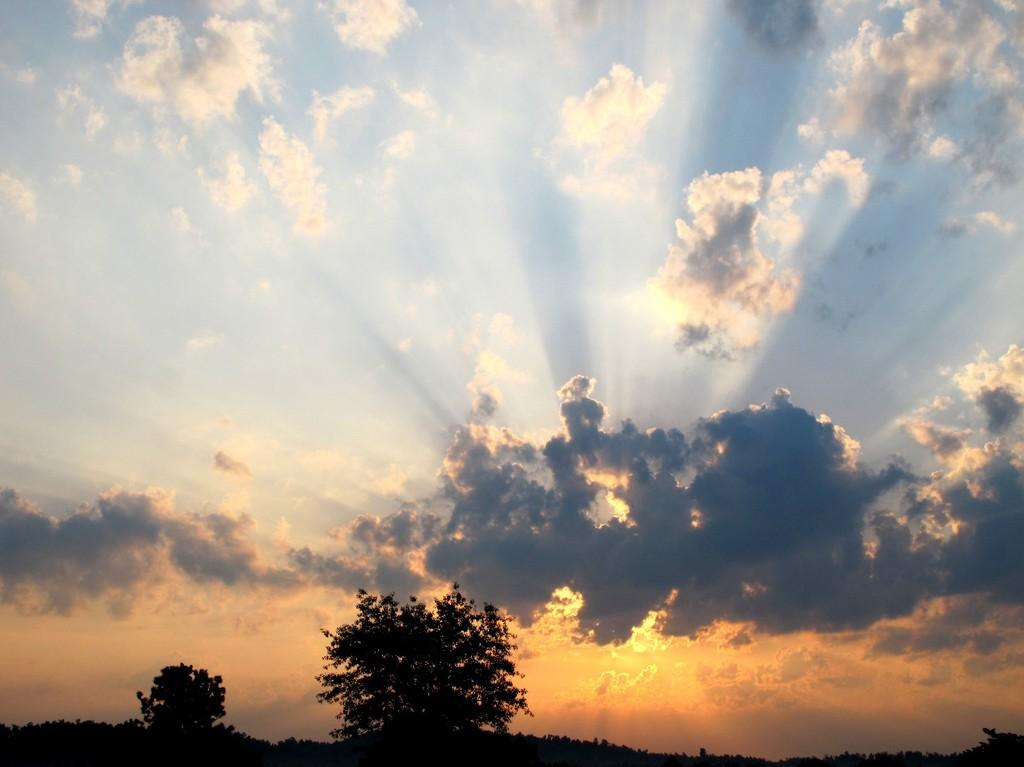What type of vegetation can be seen in the image? There are trees in the image. What can be seen in the sky in the image? There are clouds in the image. What type of insect can be seen on the branches of the trees in the image? There are no insects visible on the branches of the trees in the image. How many pets are present in the image? There are no pets present in the image. 